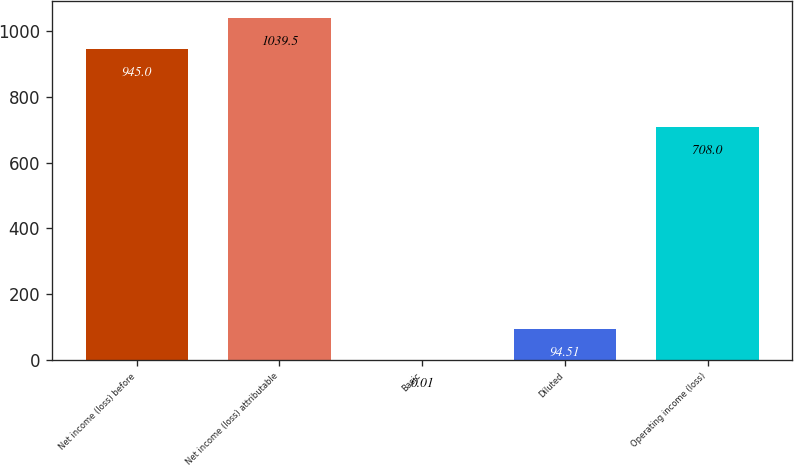<chart> <loc_0><loc_0><loc_500><loc_500><bar_chart><fcel>Net income (loss) before<fcel>Net income (loss) attributable<fcel>Basic<fcel>Diluted<fcel>Operating income (loss)<nl><fcel>945<fcel>1039.5<fcel>0.01<fcel>94.51<fcel>708<nl></chart> 